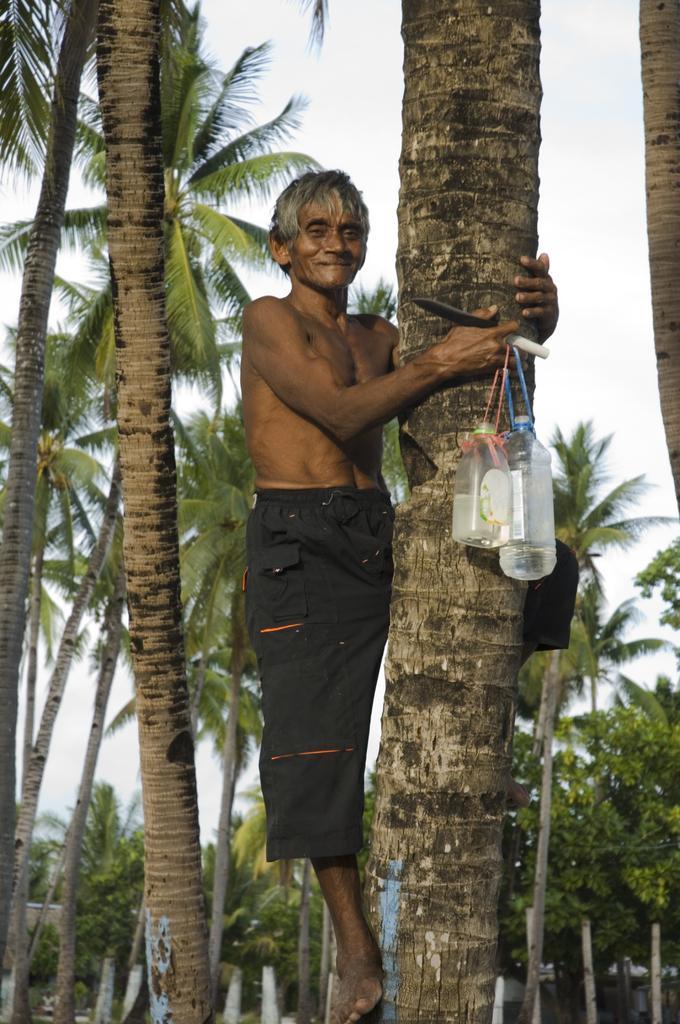Describe this image in one or two sentences. Here I can see a man is climbing a coconut tree. I can see few bottles and a knife in his hand. In the background, I can see some more coconut trees. On the top of the image I can see the sky. 